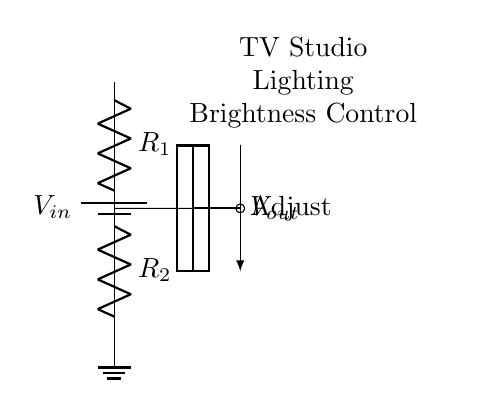What is the power supply voltage in the circuit? The circuit diagram indicates a battery labeled as V_in, which represents the input voltage of the power supply. However, the specific value of V_in is not provided in the diagram and needs to be determined from external information.
Answer: V_in What are the values of the resistors in the circuit? The circuit diagram shows two resistors labeled R_1 and R_2. The specific numerical values for these resistors are not given in the diagram; they are typically determined from circuit design specifications.
Answer: R_1 and R_2 What is the purpose of the voltage divider in this circuit? A voltage divider is designed to reduce the voltage to a desired level. In this case, it is used to control the brightness of the lighting in a TV studio by adjusting the output voltage.
Answer: Brightness control What is the output voltage when the resistors are equal? When R_1 equals R_2, the output voltage (V_out) can be expressed as half of the input voltage (V_in). This results from the voltage dividing principle, where equal resistors divide the input voltage in half.
Answer: V_in divided by 2 What component adjusts the brightness in the lighting system? The circuit diagram indicates an adjustable potentiometer (represented by the rectangle in the diagram) which is connected to the voltage divider and allows for user control over the output voltage (brightness).
Answer: Potentiometer How does changing R_1 affect output voltage? If R_1 is increased while R_2 remains constant, the output voltage (V_out) will increase, as the ratio between R_1 and R_2 dictates how much of the input voltage is dropped across each resistor. Thus, adjusting R_1 affects the division ratio, altering V_out.
Answer: Increases V_out What happens to V_out if R_2 is much larger than R_1? When R_2 is significantly larger than R_1, V_out approaches V_in because most of the input voltage drops across R_2, resulting in a small voltage drop across R_1. This scenario is typical in establishing a high output voltage level for brighter lighting conditions.
Answer: V_out approaches V_in 